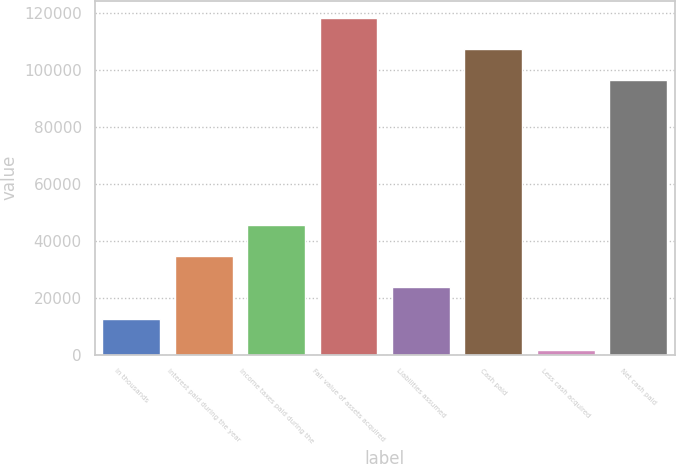<chart> <loc_0><loc_0><loc_500><loc_500><bar_chart><fcel>In thousands<fcel>Interest paid during the year<fcel>Income taxes paid during the<fcel>Fair value of assets acquired<fcel>Liabilities assumed<fcel>Cash paid<fcel>Less cash acquired<fcel>Net cash paid<nl><fcel>12544.3<fcel>34552.9<fcel>45557.2<fcel>118292<fcel>23548.6<fcel>107287<fcel>1540<fcel>96283<nl></chart> 